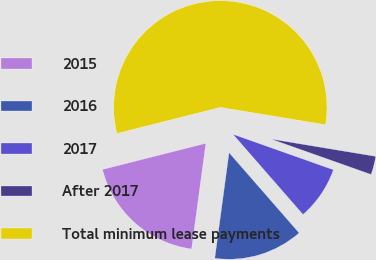Convert chart to OTSL. <chart><loc_0><loc_0><loc_500><loc_500><pie_chart><fcel>2015<fcel>2016<fcel>2017<fcel>After 2017<fcel>Total minimum lease payments<nl><fcel>18.92%<fcel>13.55%<fcel>8.17%<fcel>2.8%<fcel>56.55%<nl></chart> 